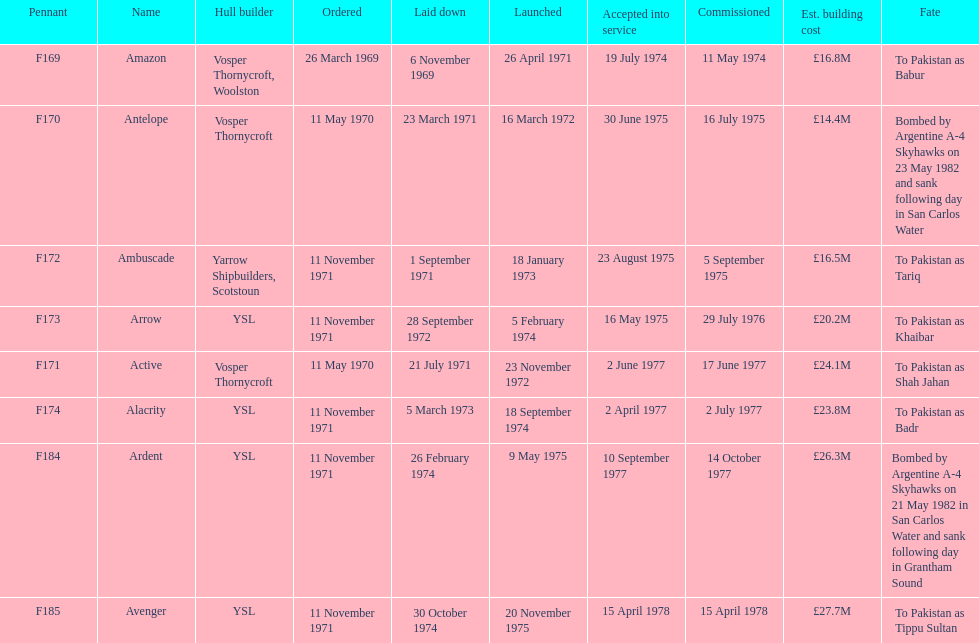Which ship was commissioned before the arrow on november 11, 1971? Ambuscade. 